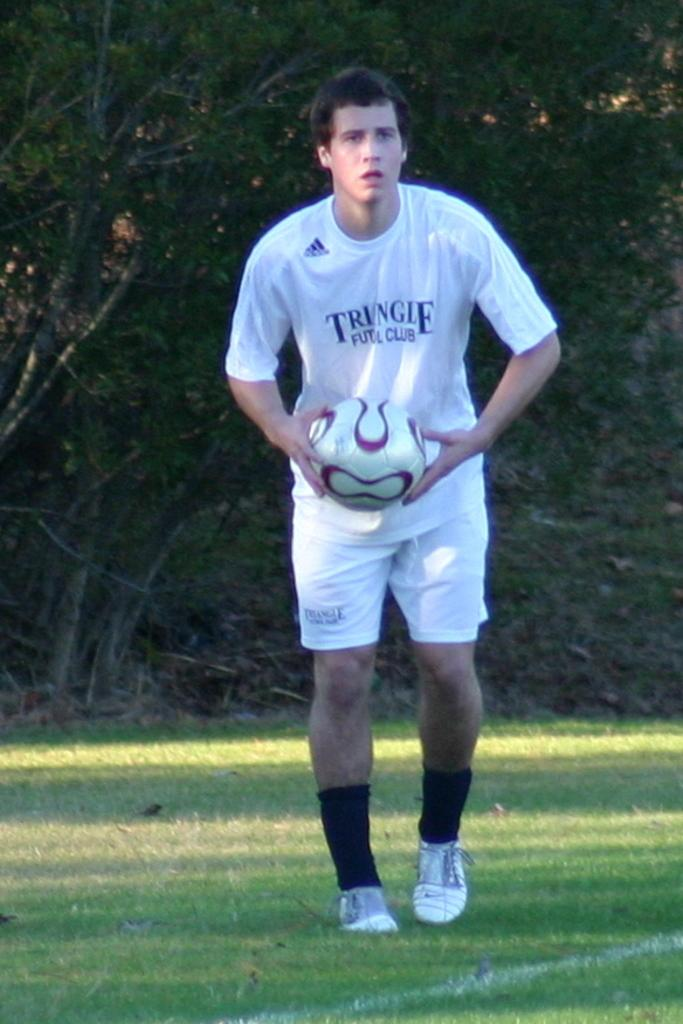Where was the image taken? The image is taken outdoors. What is the man in the image wearing? The man is wearing a white t-shirt. What is the man holding in the image? The man is holding a ball. What is the man doing in the image? The man is walking in a ground. What can be seen in the background of the image? There are trees behind the man. What type of sail can be seen on the man's shirt in the image? There is no sail present on the man's shirt in the image; he is wearing a white t-shirt. 